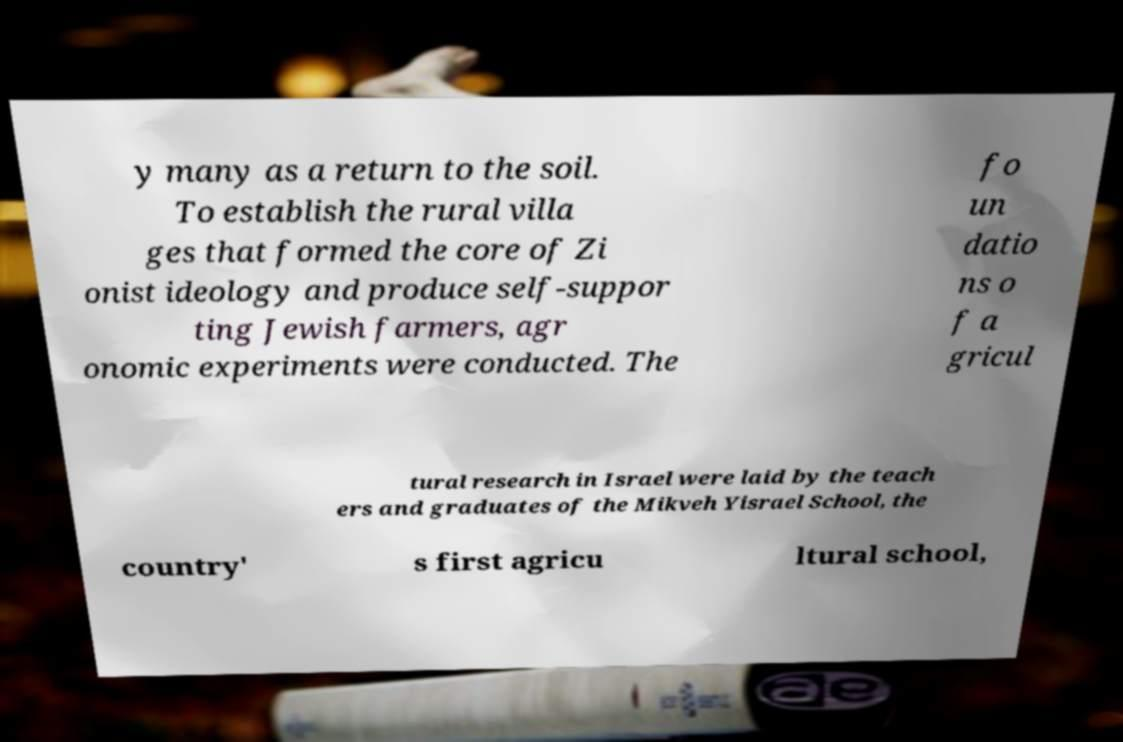For documentation purposes, I need the text within this image transcribed. Could you provide that? y many as a return to the soil. To establish the rural villa ges that formed the core of Zi onist ideology and produce self-suppor ting Jewish farmers, agr onomic experiments were conducted. The fo un datio ns o f a gricul tural research in Israel were laid by the teach ers and graduates of the Mikveh Yisrael School, the country' s first agricu ltural school, 